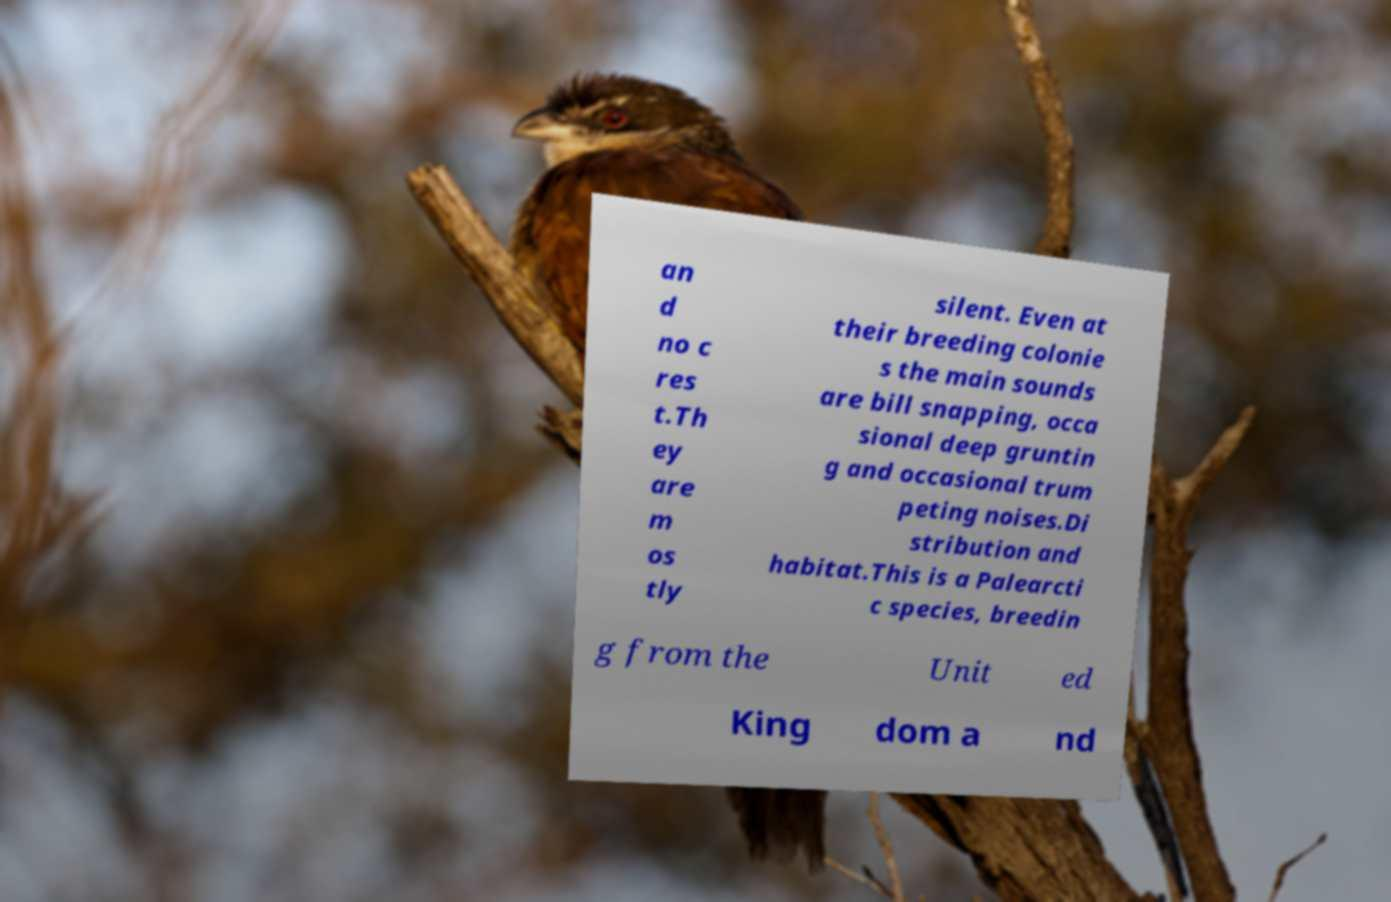Could you extract and type out the text from this image? an d no c res t.Th ey are m os tly silent. Even at their breeding colonie s the main sounds are bill snapping, occa sional deep gruntin g and occasional trum peting noises.Di stribution and habitat.This is a Palearcti c species, breedin g from the Unit ed King dom a nd 